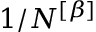<formula> <loc_0><loc_0><loc_500><loc_500>1 / N ^ { \left [ \beta \right ] }</formula> 